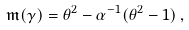Convert formula to latex. <formula><loc_0><loc_0><loc_500><loc_500>\mathfrak { m } ( \gamma ) = \theta ^ { 2 } - \alpha ^ { - 1 } ( \theta ^ { 2 } - 1 ) \, ,</formula> 